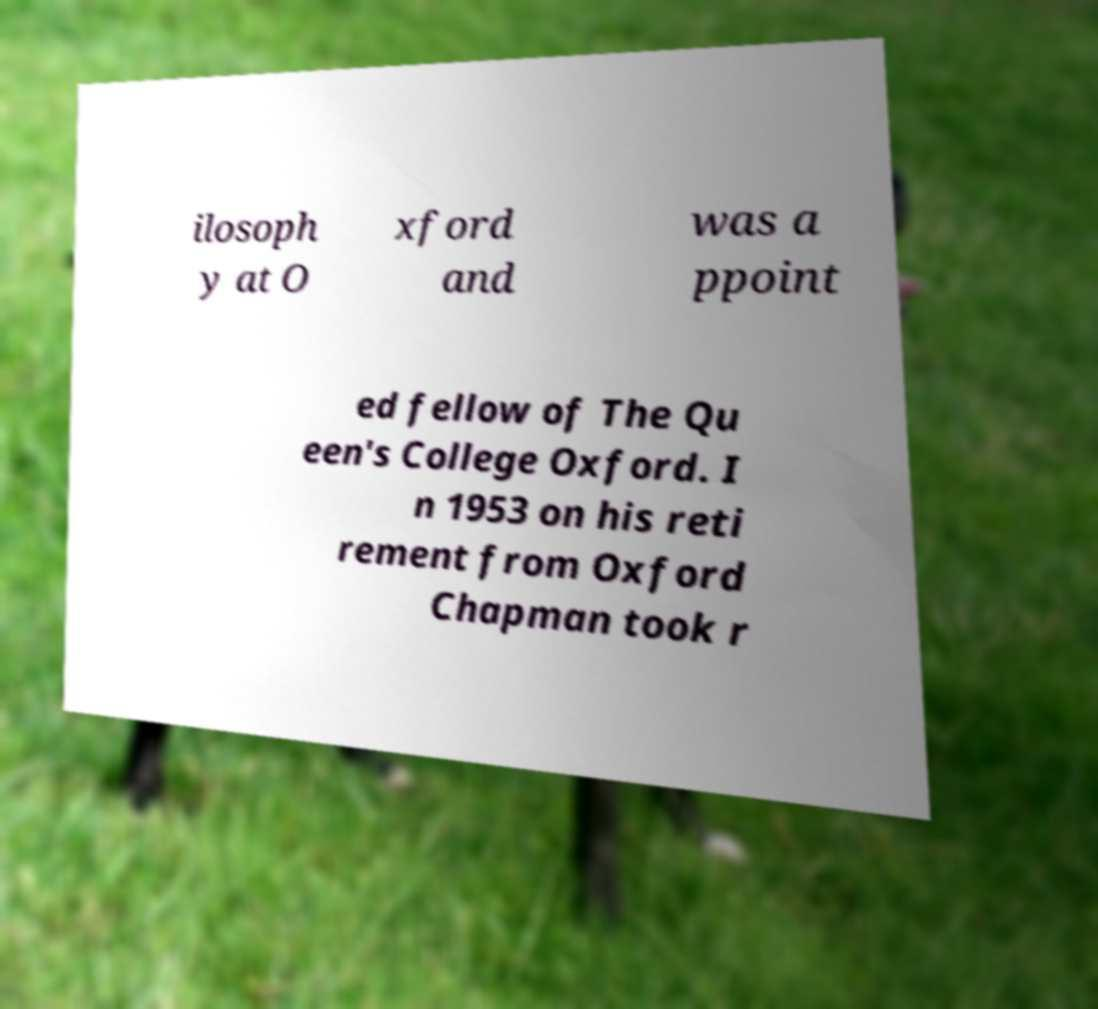Please identify and transcribe the text found in this image. ilosoph y at O xford and was a ppoint ed fellow of The Qu een's College Oxford. I n 1953 on his reti rement from Oxford Chapman took r 